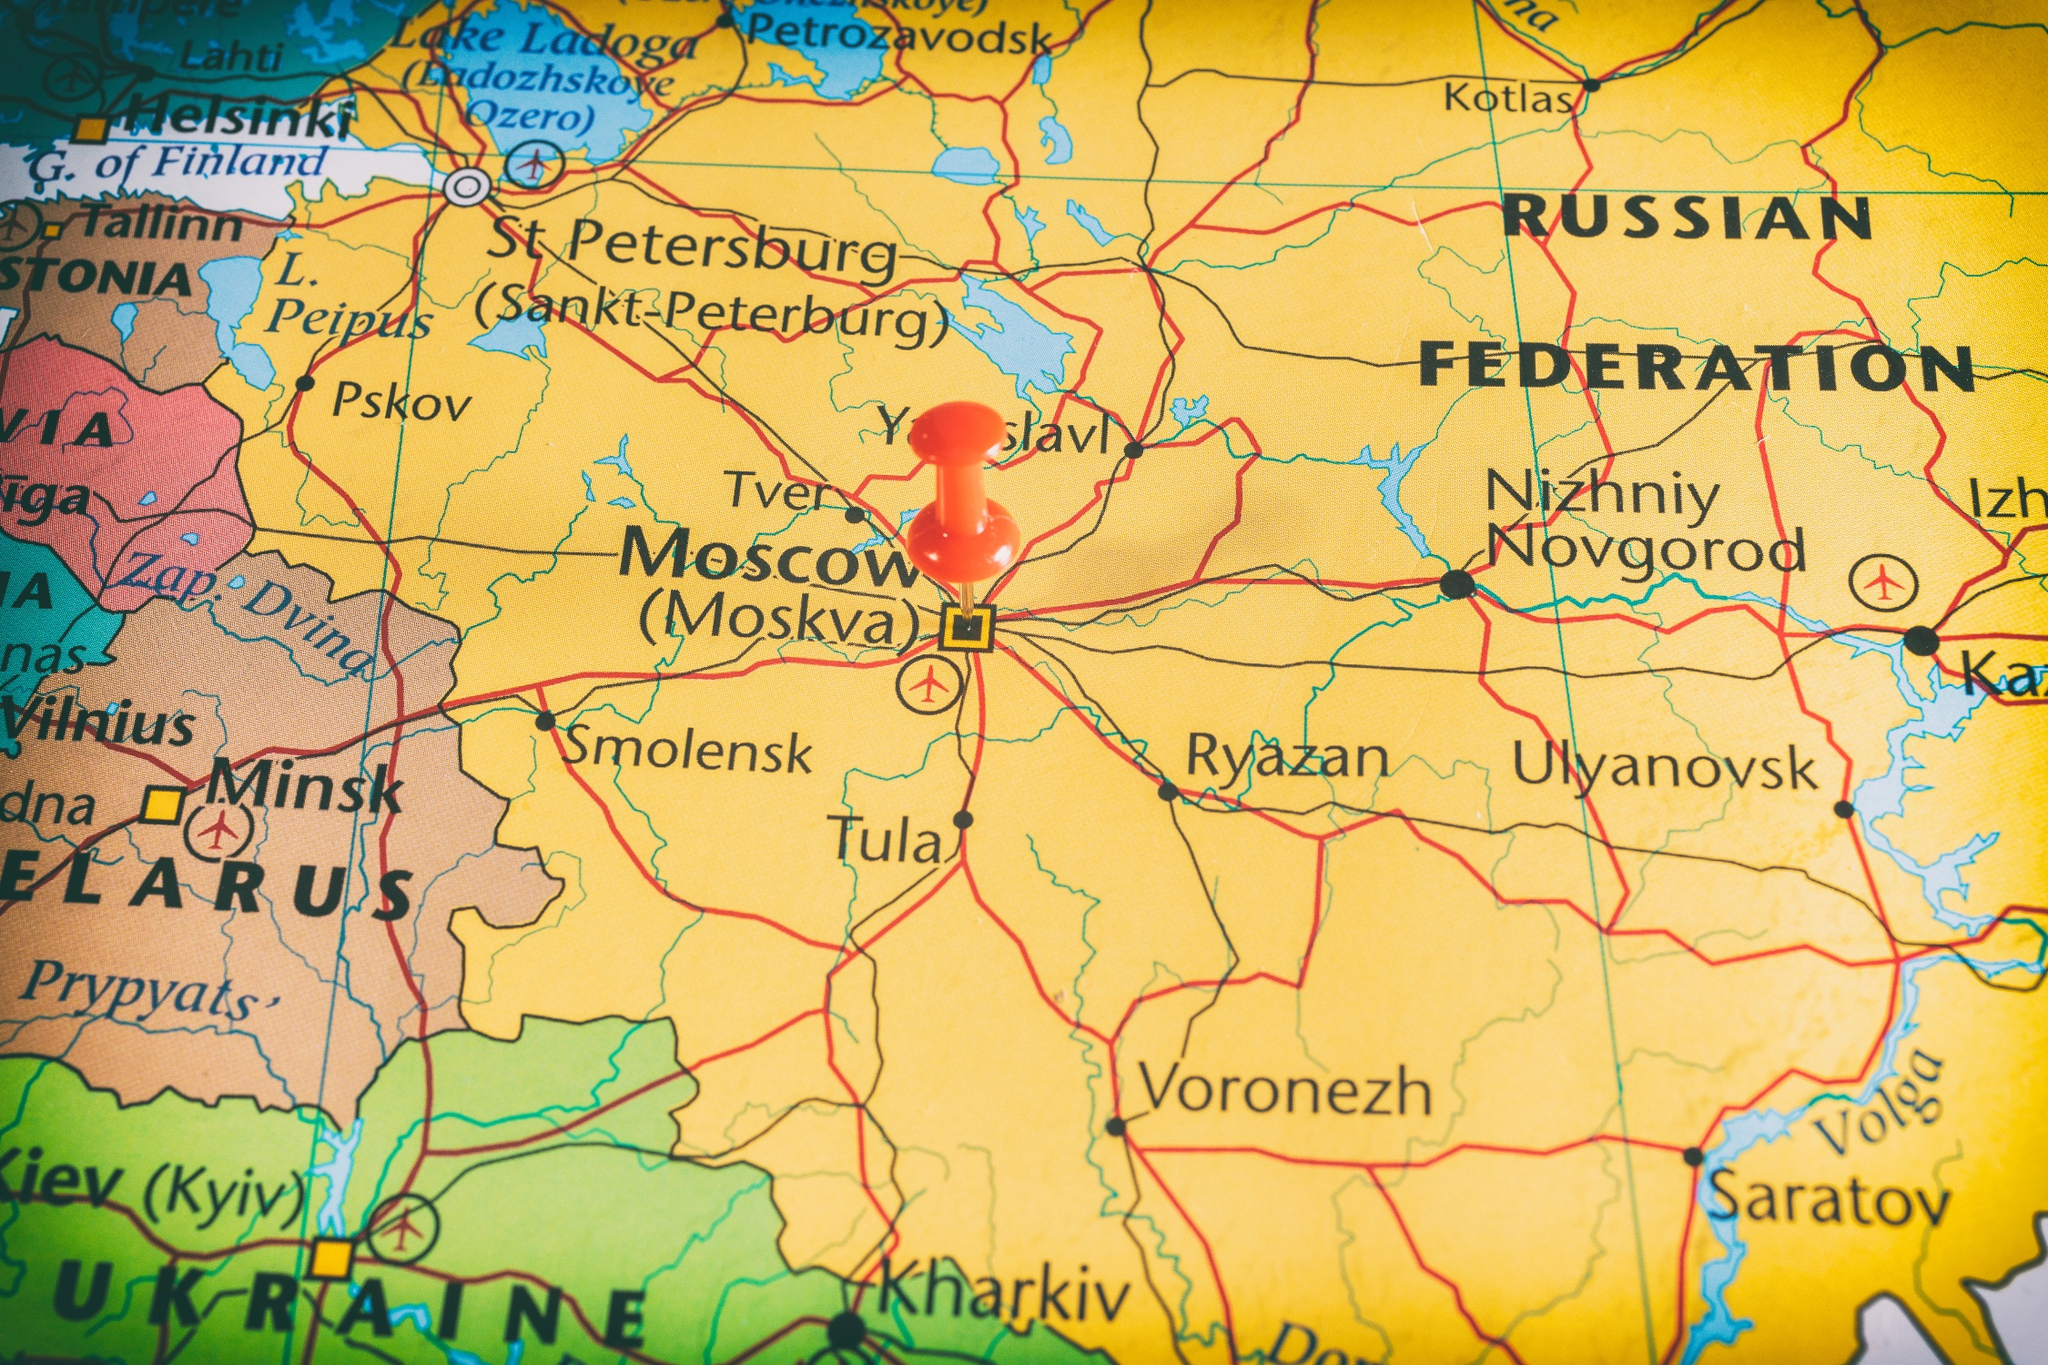How can the geographical layout seen in this map influence the socio-economic interactions between the regions? The geographical layout seen in this map significantly influences socio-economic interactions between the regions. The well-connected network of roads and proximity of major cities such as Moscow, St. Petersburg, and Nizhniy Novgorod fosters robust economic activities. The ease of transportation facilitates trade, allowing goods to move efficiently between regions, enhancing market accessibility and boosting local economies. The clustering of populous cities can lead to economic synergies, encouraging industries to thrive and promoting cultural exchanges. The strategic position of Moscow as the capital creates a centralized point for political activities, which can attract businesses, investments, and skilled labor to the region. Moreover, the map shows neighboring countries like Belarus and Ukraine, indicating potential cross-border collaborations and economic partnerships. The natural barriers and geographical features may also define local economies, with different regions specializing in various industries based on their accessibility, resources, and terrain. What might be the environmental challenges faced by the regions highlighted on this map? The regions highlighted on this map could face several environmental challenges. The extensive urbanization in cities like Moscow and St. Petersburg can lead to air and water pollution, stressing local ecosystems. The widespread transportation network, while crucial for economic activities, also contributes to increased carbon emissions and habitat fragmentation. Industrial activities in and around major cities might result in soil contamination and deterioration of air quality. The map indicates many rivers and lakes, some of which may face pollution from agricultural runoff and industrial waste, impacting local biodiversity. The wide expanse of Russia's territory also means that some regions might be vulnerable to extreme weather conditions, such as harsh winters, which can disrupt infrastructure and daily life. Additionally, climate change poses a long-term threat, potentially altering weather patterns, affecting water resources, and exacerbating existing environmental problems. Addressing these challenges would require coordinated efforts towards sustainable urban planning, pollution control, and conservation initiatives. 